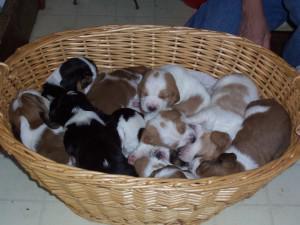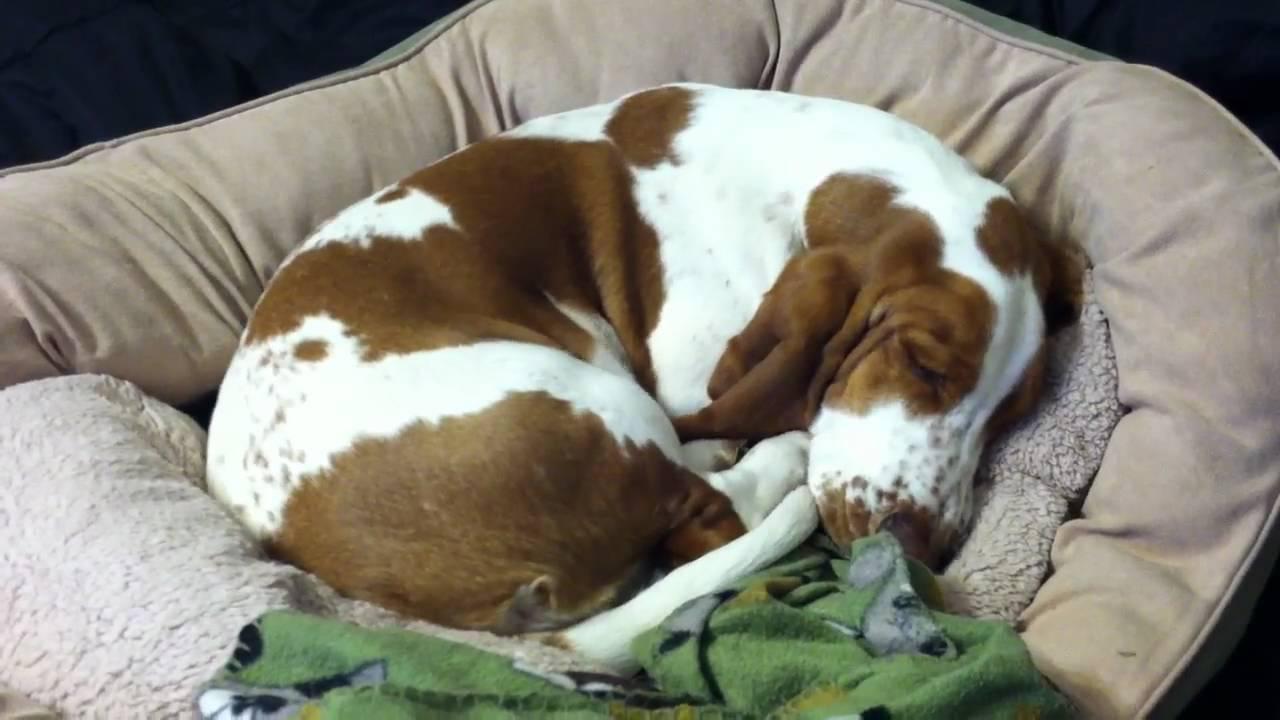The first image is the image on the left, the second image is the image on the right. Analyze the images presented: Is the assertion "There is a single dog sleeping in the image on the left." valid? Answer yes or no. No. The first image is the image on the left, the second image is the image on the right. Examine the images to the left and right. Is the description "There is no more than one sleeping dog in the right image." accurate? Answer yes or no. Yes. 